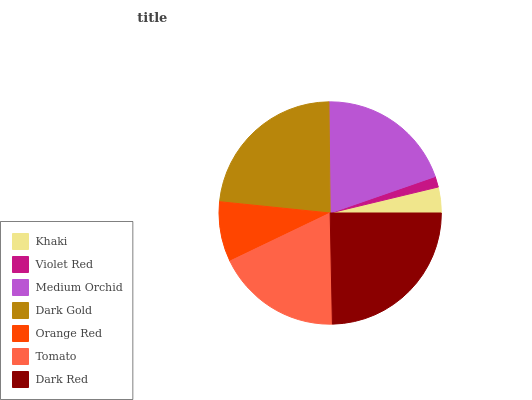Is Violet Red the minimum?
Answer yes or no. Yes. Is Dark Red the maximum?
Answer yes or no. Yes. Is Medium Orchid the minimum?
Answer yes or no. No. Is Medium Orchid the maximum?
Answer yes or no. No. Is Medium Orchid greater than Violet Red?
Answer yes or no. Yes. Is Violet Red less than Medium Orchid?
Answer yes or no. Yes. Is Violet Red greater than Medium Orchid?
Answer yes or no. No. Is Medium Orchid less than Violet Red?
Answer yes or no. No. Is Tomato the high median?
Answer yes or no. Yes. Is Tomato the low median?
Answer yes or no. Yes. Is Orange Red the high median?
Answer yes or no. No. Is Khaki the low median?
Answer yes or no. No. 